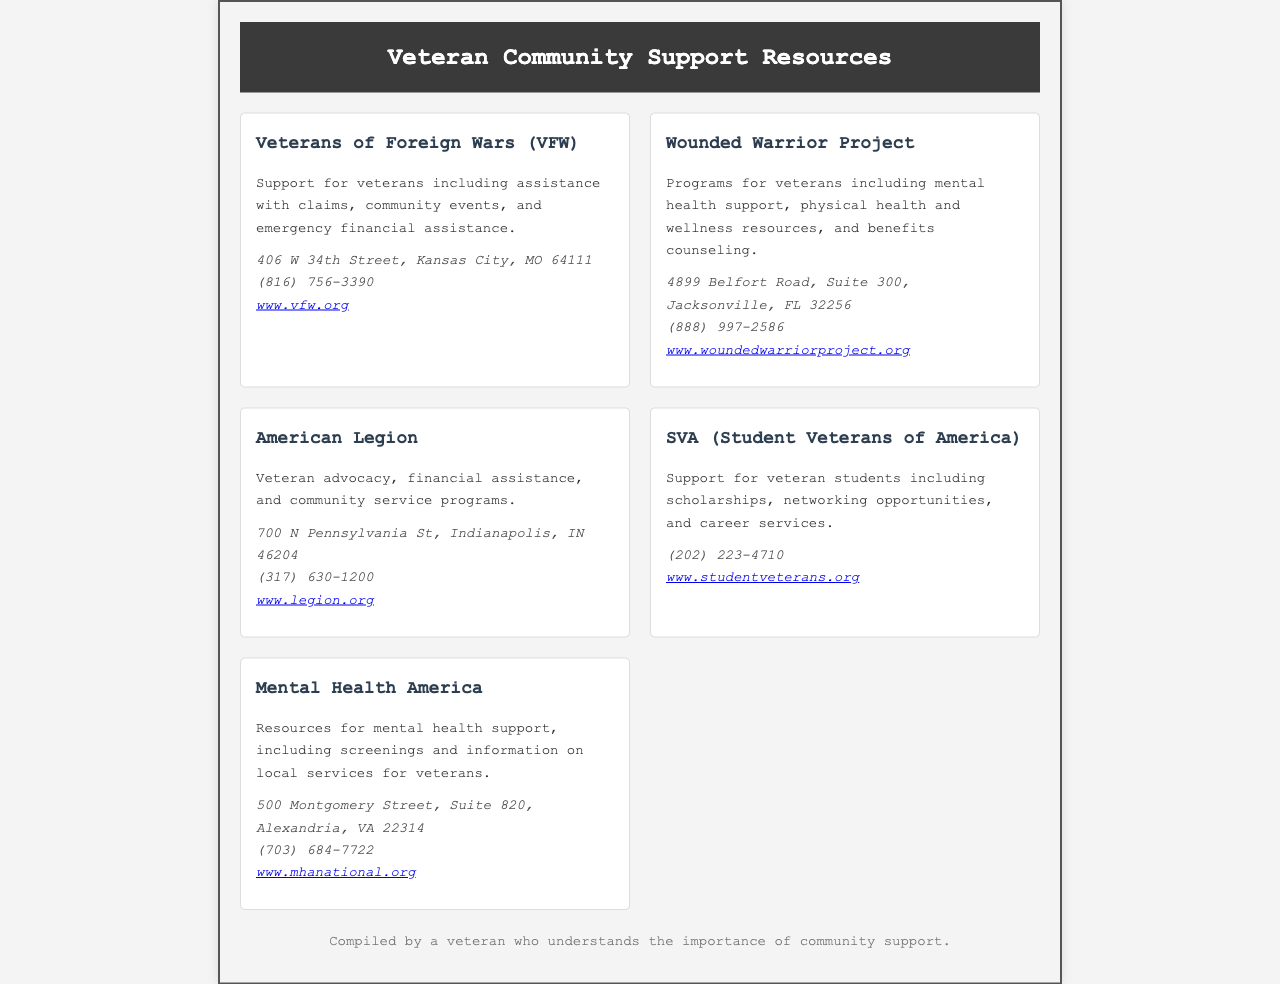What is the address of the Veterans of Foreign Wars? The address is listed in the contact section of the VFW resource in the document.
Answer: 406 W 34th Street, Kansas City, MO 64111 What organization offers mental health support for veterans? The document specifically mentions organizations that provide mental health support.
Answer: Mental Health America What is the phone number for the Wounded Warrior Project? The phone number can be found in the contact information for the Wounded Warrior Project in the document.
Answer: (888) 997-2586 How many organizations are listed in the document? The document contains multiple resources, and counting them gives the total number.
Answer: 5 Which organization supports veteran students? The document identifies specific groups that focus on veteran students, providing their names in the details.
Answer: SVA (Student Veterans of America) What type of service does the American Legion offer? The document outlines the services provided by the American Legion under their description.
Answer: Veteran advocacy, financial assistance, and community service programs What website can you visit for more information on the Wounded Warrior Project? Each organization includes a link to their website in the contact information.
Answer: www.woundedwarriorproject.org What city is the American Legion located in? The location of the American Legion can be found in its address listed in the document.
Answer: Indianapolis 